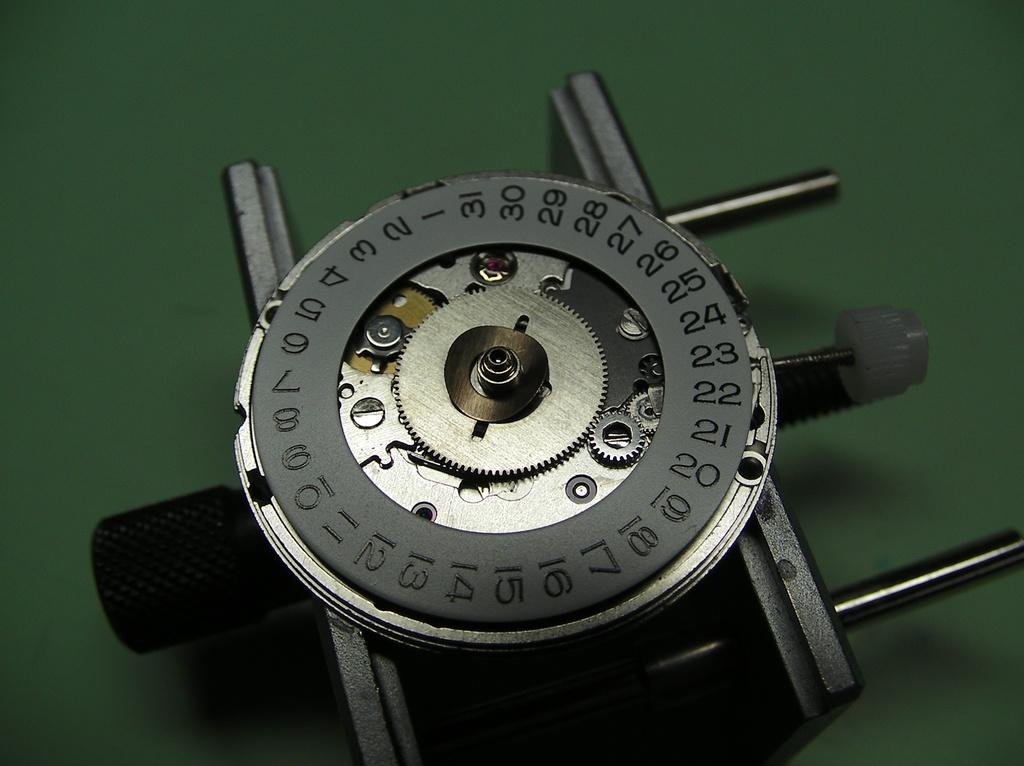<image>
Relay a brief, clear account of the picture shown. A watch face displaying the numbers 1 through 30 on a disc is sitting on a green table. 